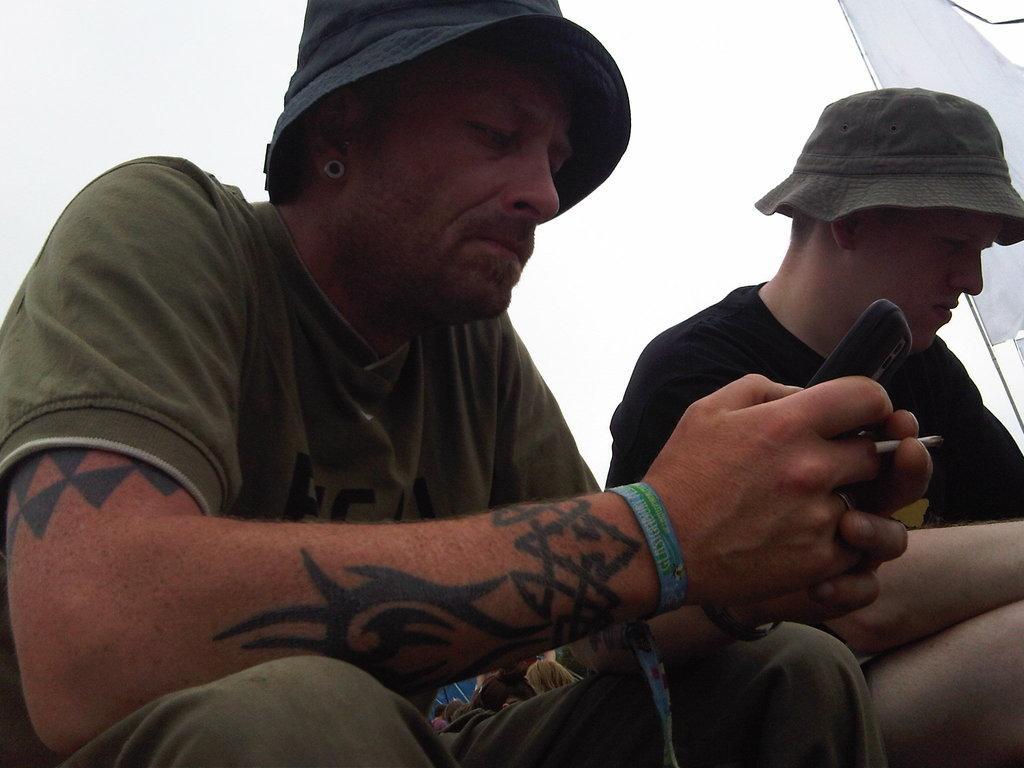Describe this image in one or two sentences. This picture is clicked outside. There are two persons wearing t-shirts and seems to be sitting on the ground. In the background we can see the sky and a white color cloth attached to the pole and we can see a mobile phone. 